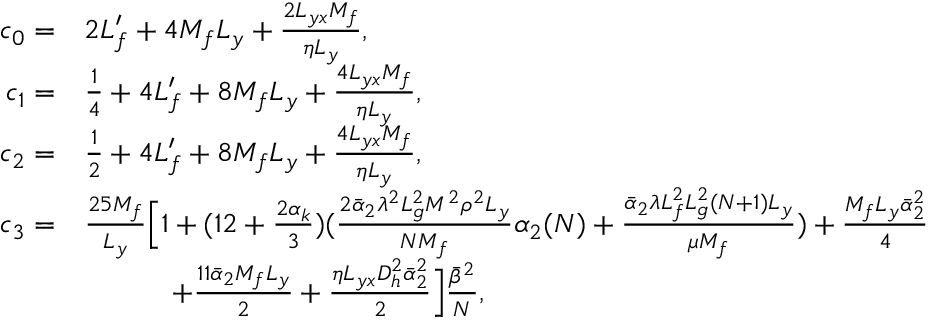<formula> <loc_0><loc_0><loc_500><loc_500>\begin{array} { r l } { c _ { 0 } = } & { 2 L _ { f } ^ { \prime } + 4 M _ { f } L _ { y } + \frac { 2 L _ { y x } M _ { f } } { \eta L _ { y } } , } \\ { c _ { 1 } = } & { \frac { 1 } { 4 } + 4 L _ { f } ^ { \prime } + 8 M _ { f } L _ { y } + \frac { 4 L _ { y x } M _ { f } } { \eta L _ { y } } , } \\ { c _ { 2 } = } & { \frac { 1 } { 2 } + 4 L _ { f } ^ { \prime } + 8 M _ { f } L _ { y } + \frac { 4 L _ { y x } M _ { f } } { \eta L _ { y } } , } \\ { c _ { 3 } = } & { \frac { 2 5 M _ { f } } { L _ { y } } \left [ 1 + ( 1 2 + \frac { 2 \alpha _ { k } } { 3 } ) ( \frac { 2 \bar { \alpha } _ { 2 } \lambda ^ { 2 } L _ { g } ^ { 2 } M ^ { 2 } \rho ^ { 2 } L _ { y } } { N M _ { f } } \alpha _ { 2 } ( N ) + \frac { \bar { \alpha } _ { 2 } \lambda L _ { f } ^ { 2 } L _ { g } ^ { 2 } ( N + 1 ) L _ { y } } { \mu M _ { f } } ) + \frac { M _ { f } L _ { y } \bar { \alpha } _ { 2 } ^ { 2 } } { 4 } } \\ & { \quad + \frac { 1 1 \bar { \alpha } _ { 2 } M _ { f } L _ { y } } { 2 } + \frac { \eta L _ { y x } D _ { h } ^ { 2 } \bar { \alpha } _ { 2 } ^ { 2 } } { 2 } \right ] \frac { \bar { \beta } ^ { 2 } } { N } , } \end{array}</formula> 